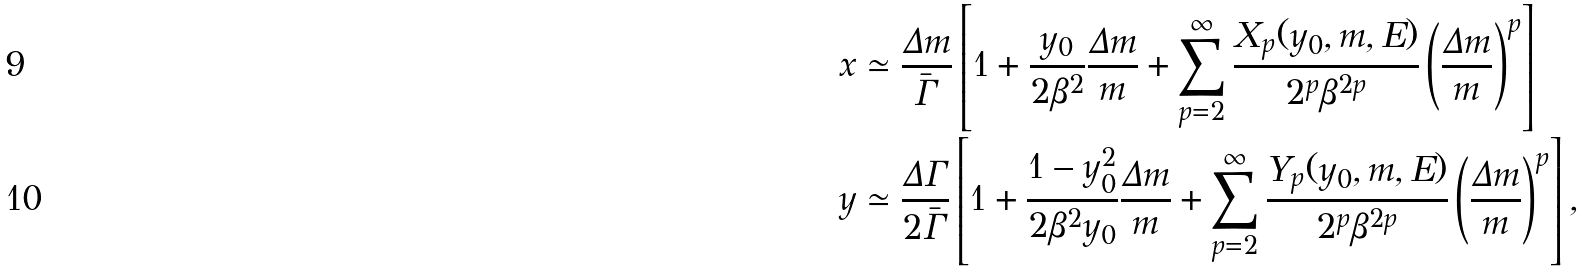Convert formula to latex. <formula><loc_0><loc_0><loc_500><loc_500>x & \simeq \frac { \Delta m } { \bar { \Gamma } } \left [ 1 + \frac { y _ { 0 } } { 2 \beta ^ { 2 } } \frac { \Delta m } { m } + \sum _ { p = 2 } ^ { \infty } \frac { X _ { p } ( y _ { 0 } , m , E ) } { 2 ^ { p } \beta ^ { 2 p } } \left ( \frac { \Delta m } { m } \right ) ^ { p } \right ] \\ y & \simeq \frac { \Delta \Gamma } { 2 \bar { \Gamma } } \left [ 1 + \frac { 1 - y _ { 0 } ^ { 2 } } { 2 \beta ^ { 2 } y _ { 0 } } \frac { \Delta m } { m } + \sum _ { p = 2 } ^ { \infty } \frac { Y _ { p } ( y _ { 0 } , m , E ) } { 2 ^ { p } \beta ^ { 2 p } } \left ( \frac { \Delta m } { m } \right ) ^ { p } \right ] ,</formula> 